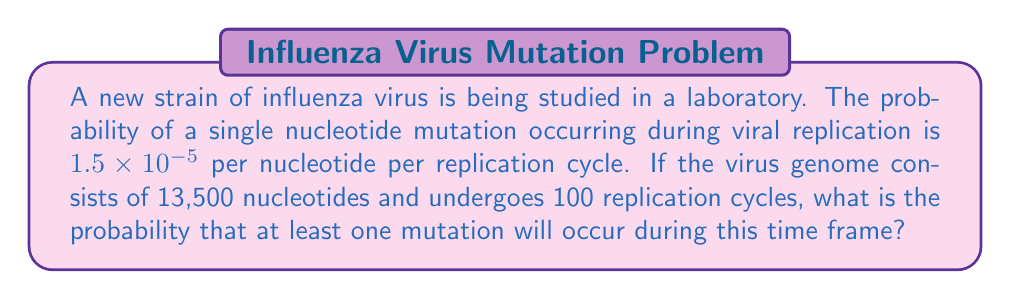Solve this math problem. To solve this problem, we'll follow these steps:

1) First, let's calculate the probability of no mutations occurring in a single nucleotide during one replication cycle:
   $P(\text{no mutation}) = 1 - (1.5 \times 10^{-5}) = 0.999985$

2) Now, for the entire genome in one replication cycle:
   $P(\text{no mutations in genome}) = (0.999985)^{13500} = 0.8175$

3) For 100 replication cycles:
   $P(\text{no mutations in 100 cycles}) = (0.8175)^{100} = 1.37 \times 10^{-9}$

4) Therefore, the probability of at least one mutation occurring is:
   $P(\text{at least one mutation}) = 1 - P(\text{no mutations})$
   $= 1 - (1.37 \times 10^{-9}) = 0.999999999$

5) Converting to scientific notation:
   $0.999999999 = 9.99999999 \times 10^{-1}$

This result indicates that it's virtually certain that at least one mutation will occur under these conditions, which is crucial information for virologists studying viral evolution and potential vaccine efficacy.
Answer: $9.99999999 \times 10^{-1}$ 